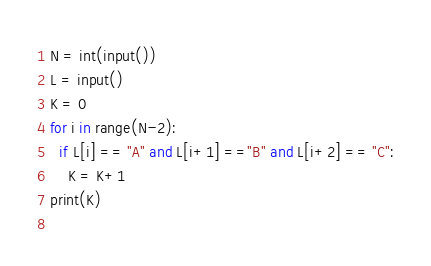Convert code to text. <code><loc_0><loc_0><loc_500><loc_500><_Python_>N = int(input())
L = input()
K = 0
for i in range(N-2):
  if L[i] == "A" and L[i+1] =="B" and L[i+2] == "C":
    K = K+1
print(K)
    </code> 